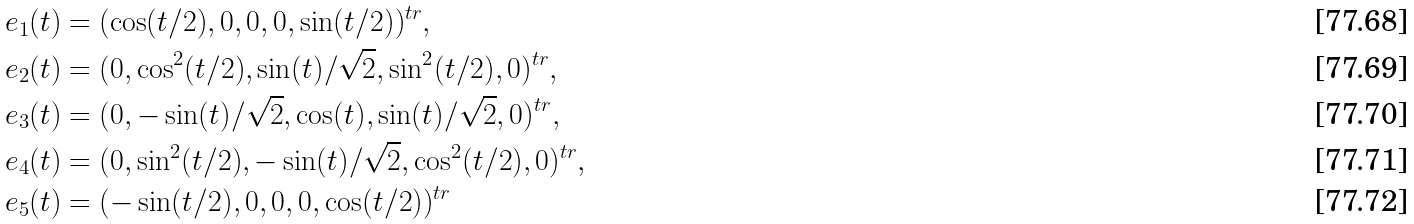<formula> <loc_0><loc_0><loc_500><loc_500>& e _ { 1 } ( t ) = ( \cos ( t / 2 ) , 0 , 0 , 0 , \sin ( t / 2 ) ) ^ { t r } , \\ & e _ { 2 } ( t ) = ( 0 , \cos ^ { 2 } ( t / 2 ) , \sin ( t ) / \sqrt { 2 } , \sin ^ { 2 } ( t / 2 ) , 0 ) ^ { t r } , \\ & e _ { 3 } ( t ) = ( 0 , - \sin ( t ) / \sqrt { 2 } , \cos ( t ) , \sin ( t ) / \sqrt { 2 } , 0 ) ^ { t r } , \\ & e _ { 4 } ( t ) = ( 0 , \sin ^ { 2 } ( t / 2 ) , - \sin ( t ) / \sqrt { 2 } , \cos ^ { 2 } ( t / 2 ) , 0 ) ^ { t r } , \\ & e _ { 5 } ( t ) = ( - \sin ( t / 2 ) , 0 , 0 , 0 , \cos ( t / 2 ) ) ^ { t r }</formula> 